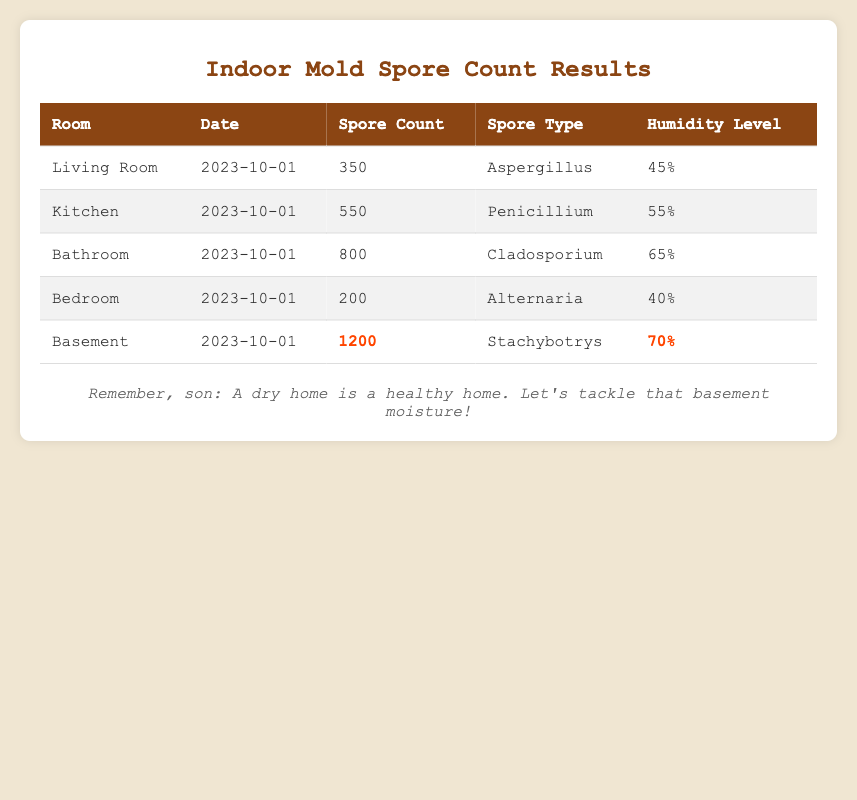What is the spore count in the Living Room? Looking at the table, the spore count for the Living Room on the date 2023-10-01 is listed in the corresponding row. It states the spore count is 350.
Answer: 350 Which room has the highest spore count? To find the highest spore count, we look at the "Spore Count" column and identify the maximum value. The Basement has the highest spore count of 1200.
Answer: Basement Is the humidity level in the Bathroom higher than in the Bedroom? We can compare the "Humidity Level" values for the Bathroom (65%) and Bedroom (40%). Since 65% is greater than 40%, the humidity level in the Bathroom is higher.
Answer: Yes What is the average spore count across all rooms? To compute the average, we first sum all the spore counts: 350 + 550 + 800 + 200 + 1200 = 3100. There are 5 rooms, so we divide 3100 by 5, giving us an average spore count of 620.
Answer: 620 Is there a spore type present in both the Kitchen and Bathroom? The spore types for the Kitchen (Penicillium) and Bathroom (Cladosporium) are different when checked. Hence, there is no common spore type between them.
Answer: No What is the difference in spore count between the Basement and the Bedroom? By looking at both rows, the Basement has a spore count of 1200, and the Bedroom has 200. We subtract the Bedroom count from the Basement count: 1200 - 200 = 1000.
Answer: 1000 How many rooms have a humidity level above 50%? Checking the "Humidity Level" column, the Kitchen (55%), Bathroom (65%), and Basement (70%) all exceed 50%. Thus, there are three rooms above this humidity level.
Answer: 3 Does the Bathroom have a higher spore count than the Kitchen? The Bathroom spore count is 800, and the Kitchen is 550. Since 800 is greater than 550, the answer would be that the Bathroom does indeed have a higher count.
Answer: Yes What is the spore type recorded in the Basement? In the row for the Basement, the spore type is listed as Stachybotrys. This is a direct retrieval from the "Spore Type" column under Basement.
Answer: Stachybotrys 